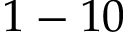Convert formula to latex. <formula><loc_0><loc_0><loc_500><loc_500>1 - 1 0</formula> 